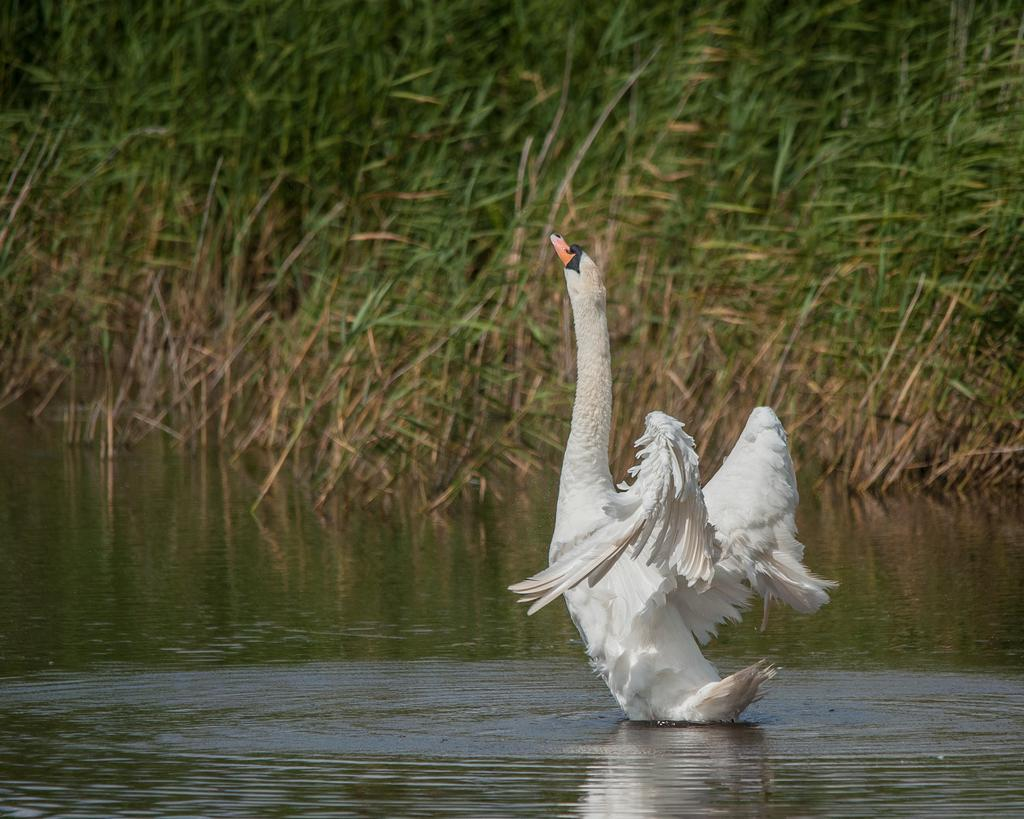What animal is in the image? There is a swan in the image. Where is the swan located? The swan is on the water. What else can be seen in the water besides the swan? There are plants in the water. What type of writer can be seen sitting near the swan in the image? There is no writer present in the image; it only features a swan on the water with plants. 